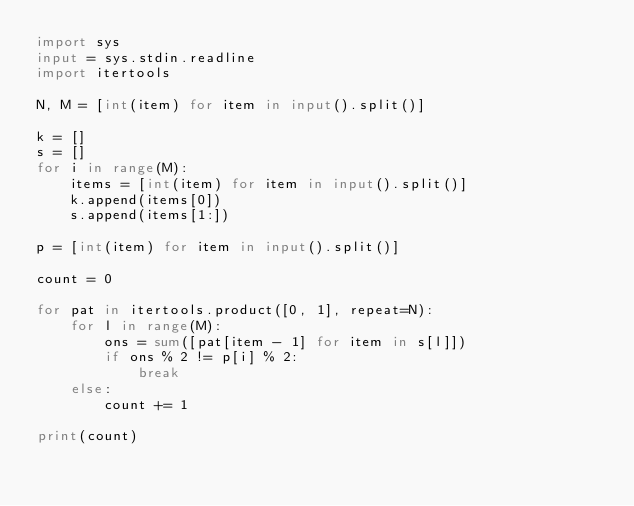Convert code to text. <code><loc_0><loc_0><loc_500><loc_500><_Python_>import sys
input = sys.stdin.readline
import itertools

N, M = [int(item) for item in input().split()]

k = []
s = []
for i in range(M):
    items = [int(item) for item in input().split()]
    k.append(items[0])
    s.append(items[1:])

p = [int(item) for item in input().split()]

count = 0

for pat in itertools.product([0, 1], repeat=N):
    for l in range(M):
        ons = sum([pat[item - 1] for item in s[l]])
        if ons % 2 != p[i] % 2:
            break
    else:
        count += 1

print(count)
</code> 